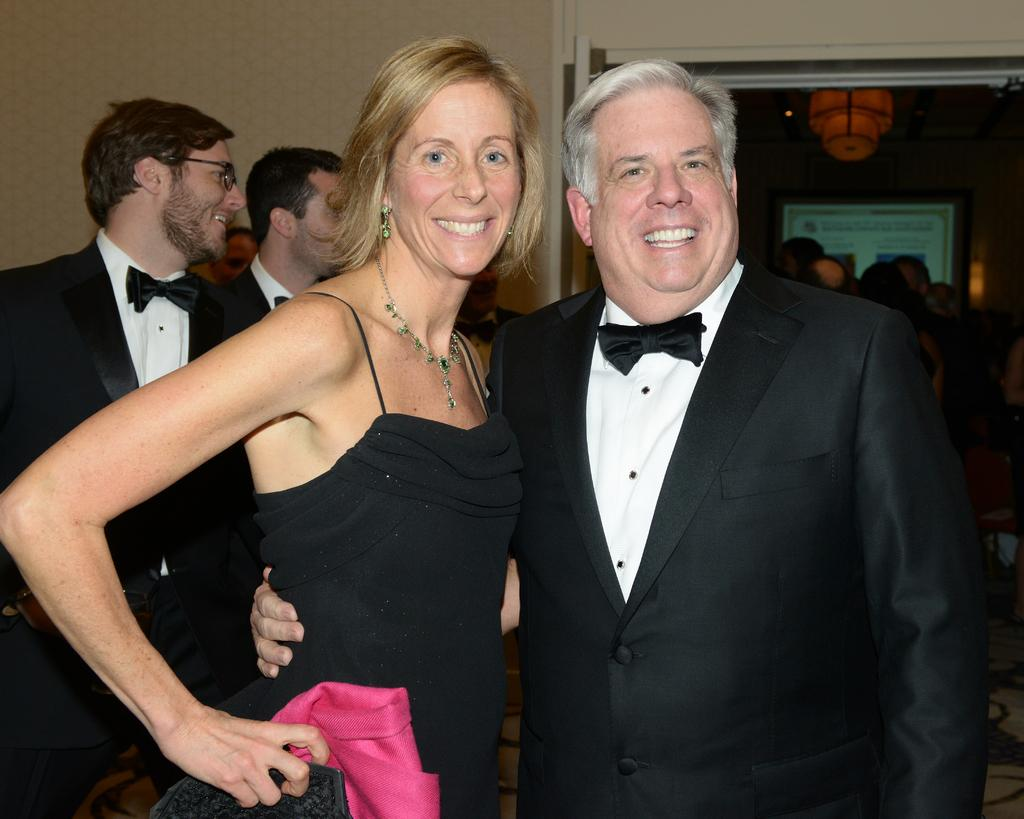How many people are in the image? There are persons in the image, but the exact number is not specified. What are the persons wearing? The persons are wearing clothes. What can be seen in the top left of the image? There is a wall in the top left of the image. What type of heart can be seen beating in the image? There is no heart visible in the image. Can you describe the tramp that is jumping in the image? There is no tramp or jumping activity depicted in the image. 